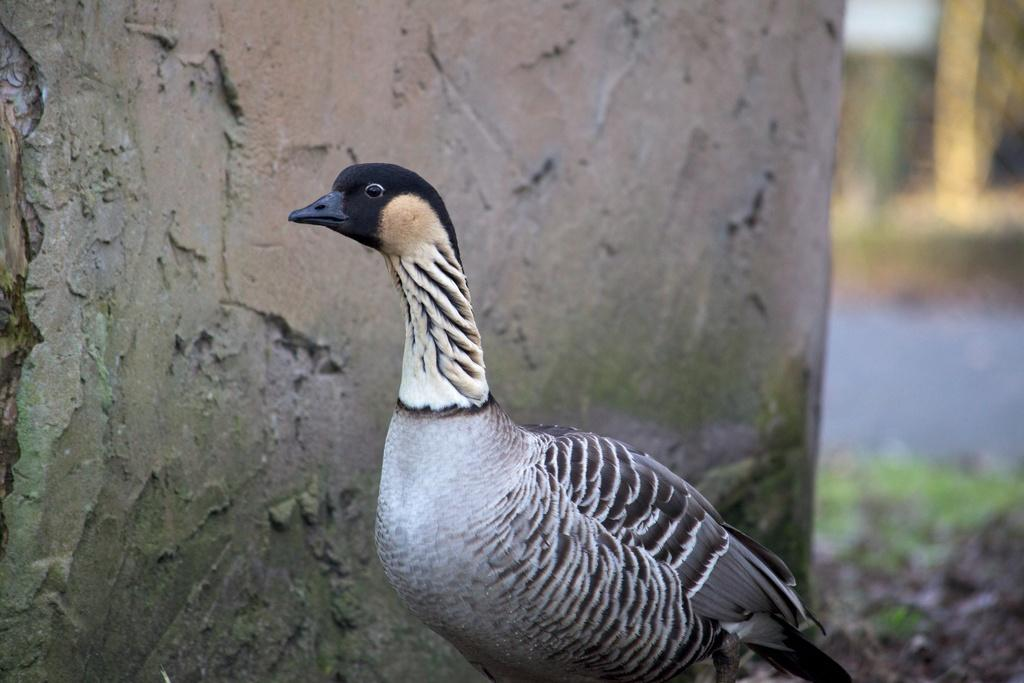What type of animal can be seen in the image? There is a bird in the image. Where is the bird located? The bird is standing on the land. What colors does the bird have? The bird is in white and black color. What is beside the bird? There is a wall beside the bird. How would you describe the background of the image? The background of the image is blurry. What type of dress is the bird wearing in the image? Birds do not wear dresses, so there is no dress present in the image. 